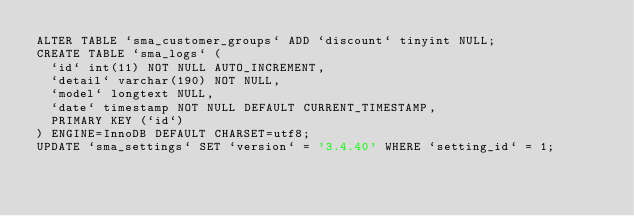<code> <loc_0><loc_0><loc_500><loc_500><_SQL_>ALTER TABLE `sma_customer_groups` ADD `discount` tinyint NULL;
CREATE TABLE `sma_logs` (
  `id` int(11) NOT NULL AUTO_INCREMENT,
  `detail` varchar(190) NOT NULL,
  `model` longtext NULL,
  `date` timestamp NOT NULL DEFAULT CURRENT_TIMESTAMP,
  PRIMARY KEY (`id`)
) ENGINE=InnoDB DEFAULT CHARSET=utf8;
UPDATE `sma_settings` SET `version` = '3.4.40' WHERE `setting_id` = 1;
</code> 